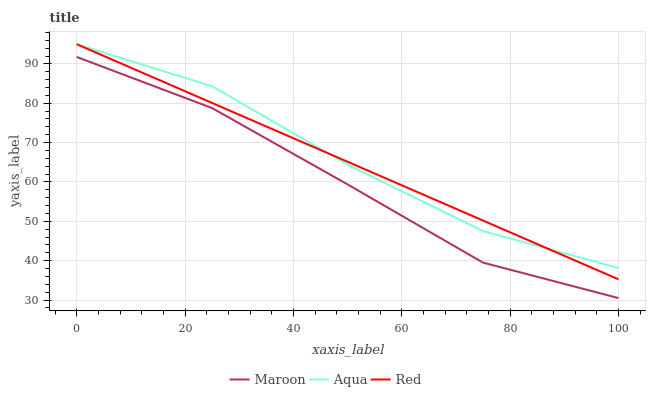Does Maroon have the minimum area under the curve?
Answer yes or no. Yes. Does Aqua have the maximum area under the curve?
Answer yes or no. Yes. Does Red have the minimum area under the curve?
Answer yes or no. No. Does Red have the maximum area under the curve?
Answer yes or no. No. Is Red the smoothest?
Answer yes or no. Yes. Is Aqua the roughest?
Answer yes or no. Yes. Is Maroon the smoothest?
Answer yes or no. No. Is Maroon the roughest?
Answer yes or no. No. Does Maroon have the lowest value?
Answer yes or no. Yes. Does Red have the lowest value?
Answer yes or no. No. Does Red have the highest value?
Answer yes or no. Yes. Does Maroon have the highest value?
Answer yes or no. No. Is Maroon less than Aqua?
Answer yes or no. Yes. Is Aqua greater than Maroon?
Answer yes or no. Yes. Does Aqua intersect Red?
Answer yes or no. Yes. Is Aqua less than Red?
Answer yes or no. No. Is Aqua greater than Red?
Answer yes or no. No. Does Maroon intersect Aqua?
Answer yes or no. No. 